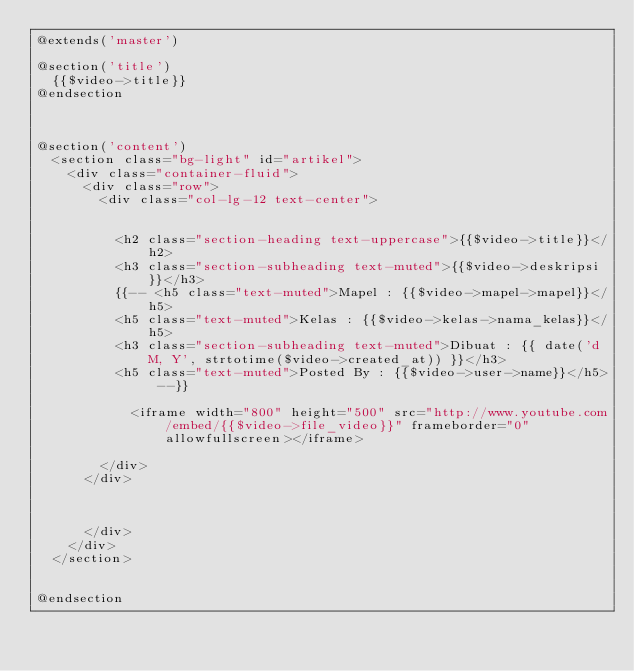<code> <loc_0><loc_0><loc_500><loc_500><_PHP_>@extends('master')

@section('title')
  {{$video->title}}
@endsection



@section('content')
  <section class="bg-light" id="artikel">
    <div class="container-fluid">
      <div class="row">
        <div class="col-lg-12 text-center">


          <h2 class="section-heading text-uppercase">{{$video->title}}</h2>
          <h3 class="section-subheading text-muted">{{$video->deskripsi}}</h3>
          {{-- <h5 class="text-muted">Mapel : {{$video->mapel->mapel}}</h5>
          <h5 class="text-muted">Kelas : {{$video->kelas->nama_kelas}}</h5>
          <h3 class="section-subheading text-muted">Dibuat : {{ date('d M, Y', strtotime($video->created_at)) }}</h3>
          <h5 class="text-muted">Posted By : {{$video->user->name}}</h5> --}}

            <iframe width="800" height="500" src="http://www.youtube.com/embed/{{$video->file_video}}" frameborder="0" allowfullscreen></iframe>

        </div>
      </div>



      </div>
    </div>
  </section>


@endsection
</code> 